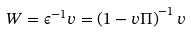Convert formula to latex. <formula><loc_0><loc_0><loc_500><loc_500>W = \epsilon ^ { - 1 } v = \left ( 1 - v \Pi \right ) ^ { - 1 } v</formula> 